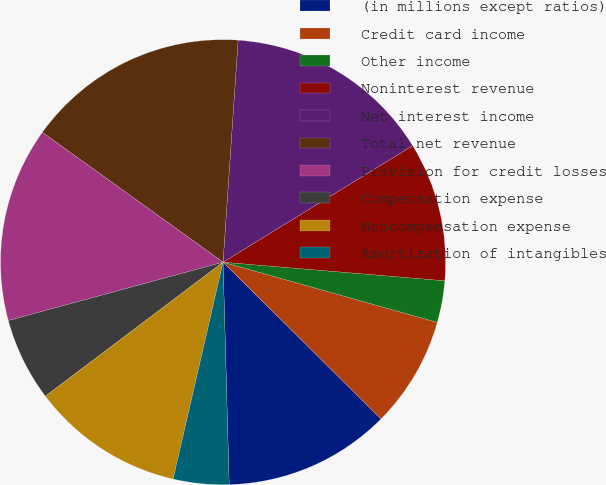Convert chart. <chart><loc_0><loc_0><loc_500><loc_500><pie_chart><fcel>(in millions except ratios)<fcel>Credit card income<fcel>Other income<fcel>Noninterest revenue<fcel>Net interest income<fcel>Total net revenue<fcel>Provision for credit losses<fcel>Compensation expense<fcel>Noncompensation expense<fcel>Amortization of intangibles<nl><fcel>12.12%<fcel>8.08%<fcel>3.03%<fcel>10.1%<fcel>15.15%<fcel>16.16%<fcel>14.14%<fcel>6.06%<fcel>11.11%<fcel>4.04%<nl></chart> 